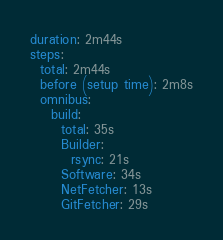<code> <loc_0><loc_0><loc_500><loc_500><_YAML_>duration: 2m44s
steps:
  total: 2m44s
  before (setup time): 2m8s
  omnibus:
    build:
      total: 35s
      Builder:
        rsync: 21s
      Software: 34s
      NetFetcher: 13s
      GitFetcher: 29s
</code> 